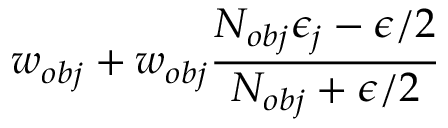<formula> <loc_0><loc_0><loc_500><loc_500>w _ { o b j } + w _ { o b j } \frac { N _ { o b j } \epsilon _ { j } - \epsilon / 2 } { N _ { o b j } + \epsilon / 2 }</formula> 